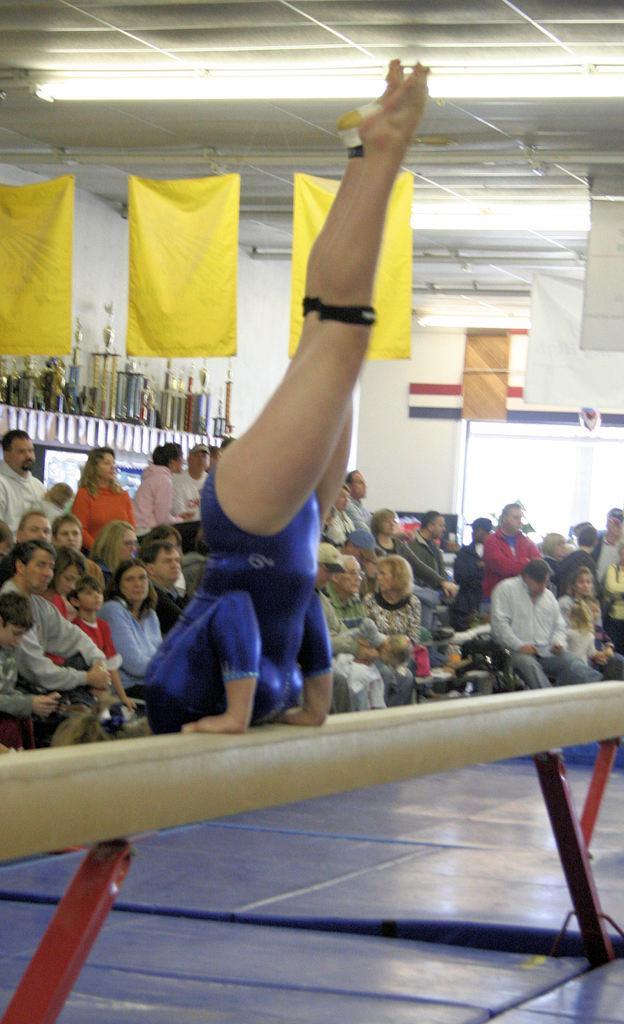In one or two sentences, can you explain what this image depicts? In the image there is a rod. On the road there is a lady in inverted position. Behind her there are few people sitting and few of them are standing. And also there are yellow flags. In the background there are walls and few other items. To the top of the image there is a roof with light. 